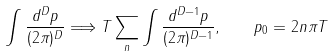Convert formula to latex. <formula><loc_0><loc_0><loc_500><loc_500>\int \frac { d ^ { D } p } { ( 2 \pi ) ^ { D } } \Longrightarrow T \sum _ { n } \int \frac { d ^ { D - 1 } p } { ( 2 \pi ) ^ { D - 1 } } , \quad p _ { 0 } = 2 n \pi T</formula> 